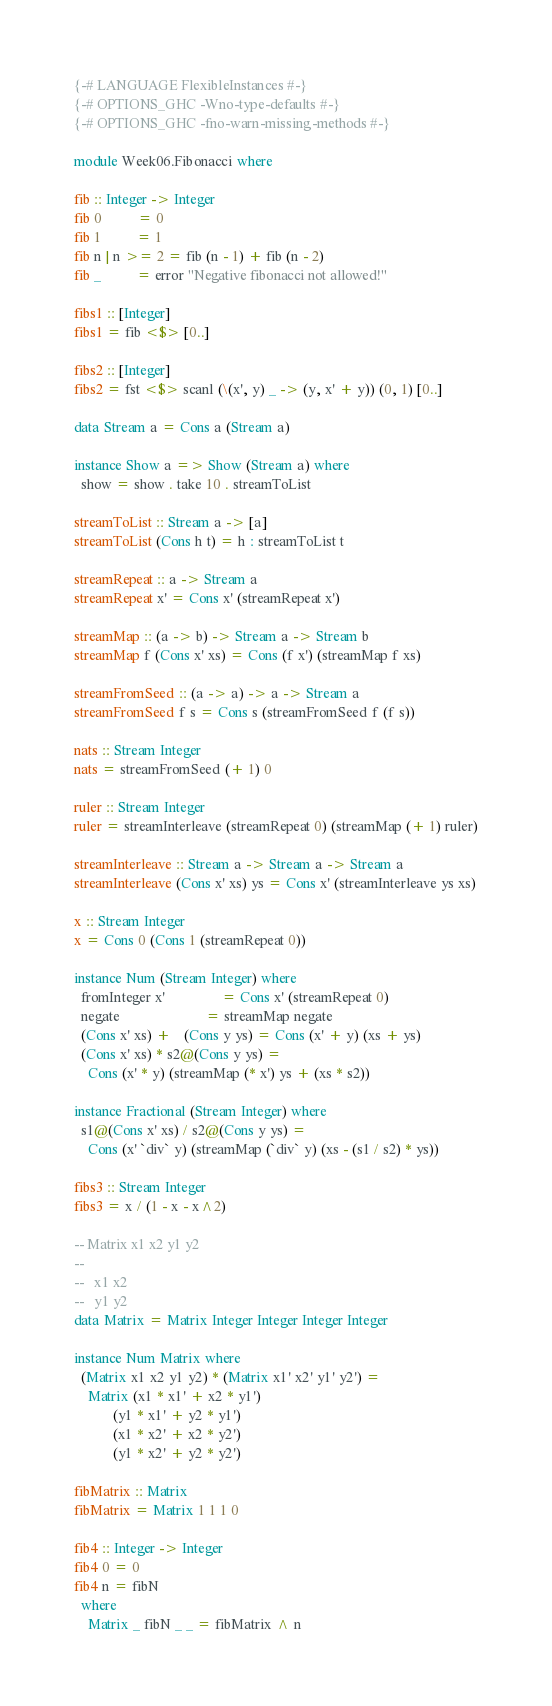Convert code to text. <code><loc_0><loc_0><loc_500><loc_500><_Haskell_>{-# LANGUAGE FlexibleInstances #-}
{-# OPTIONS_GHC -Wno-type-defaults #-}
{-# OPTIONS_GHC -fno-warn-missing-methods #-}

module Week06.Fibonacci where

fib :: Integer -> Integer
fib 0          = 0
fib 1          = 1
fib n | n >= 2 = fib (n - 1) + fib (n - 2)
fib _          = error "Negative fibonacci not allowed!"

fibs1 :: [Integer]
fibs1 = fib <$> [0..]

fibs2 :: [Integer]
fibs2 = fst <$> scanl (\(x', y) _ -> (y, x' + y)) (0, 1) [0..]

data Stream a = Cons a (Stream a)

instance Show a => Show (Stream a) where
  show = show . take 10 . streamToList

streamToList :: Stream a -> [a]
streamToList (Cons h t) = h : streamToList t

streamRepeat :: a -> Stream a
streamRepeat x' = Cons x' (streamRepeat x')

streamMap :: (a -> b) -> Stream a -> Stream b
streamMap f (Cons x' xs) = Cons (f x') (streamMap f xs)

streamFromSeed :: (a -> a) -> a -> Stream a
streamFromSeed f s = Cons s (streamFromSeed f (f s))

nats :: Stream Integer
nats = streamFromSeed (+ 1) 0

ruler :: Stream Integer
ruler = streamInterleave (streamRepeat 0) (streamMap (+ 1) ruler)

streamInterleave :: Stream a -> Stream a -> Stream a
streamInterleave (Cons x' xs) ys = Cons x' (streamInterleave ys xs)

x :: Stream Integer
x = Cons 0 (Cons 1 (streamRepeat 0))

instance Num (Stream Integer) where
  fromInteger x'                = Cons x' (streamRepeat 0)
  negate                        = streamMap negate
  (Cons x' xs) +    (Cons y ys) = Cons (x' + y) (xs + ys)
  (Cons x' xs) * s2@(Cons y ys) =
    Cons (x' * y) (streamMap (* x') ys + (xs * s2))

instance Fractional (Stream Integer) where
  s1@(Cons x' xs) / s2@(Cons y ys) =
    Cons (x' `div` y) (streamMap (`div` y) (xs - (s1 / s2) * ys))

fibs3 :: Stream Integer
fibs3 = x / (1 - x - x^2)

-- Matrix x1 x2 y1 y2
--
--   x1 x2
--   y1 y2
data Matrix = Matrix Integer Integer Integer Integer

instance Num Matrix where
  (Matrix x1 x2 y1 y2) * (Matrix x1' x2' y1' y2') =
    Matrix (x1 * x1' + x2 * y1')
           (y1 * x1' + y2 * y1')
           (x1 * x2' + x2 * y2')
           (y1 * x2' + y2 * y2')

fibMatrix :: Matrix
fibMatrix = Matrix 1 1 1 0

fib4 :: Integer -> Integer
fib4 0 = 0
fib4 n = fibN
  where
    Matrix _ fibN _ _ = fibMatrix ^ n
</code> 